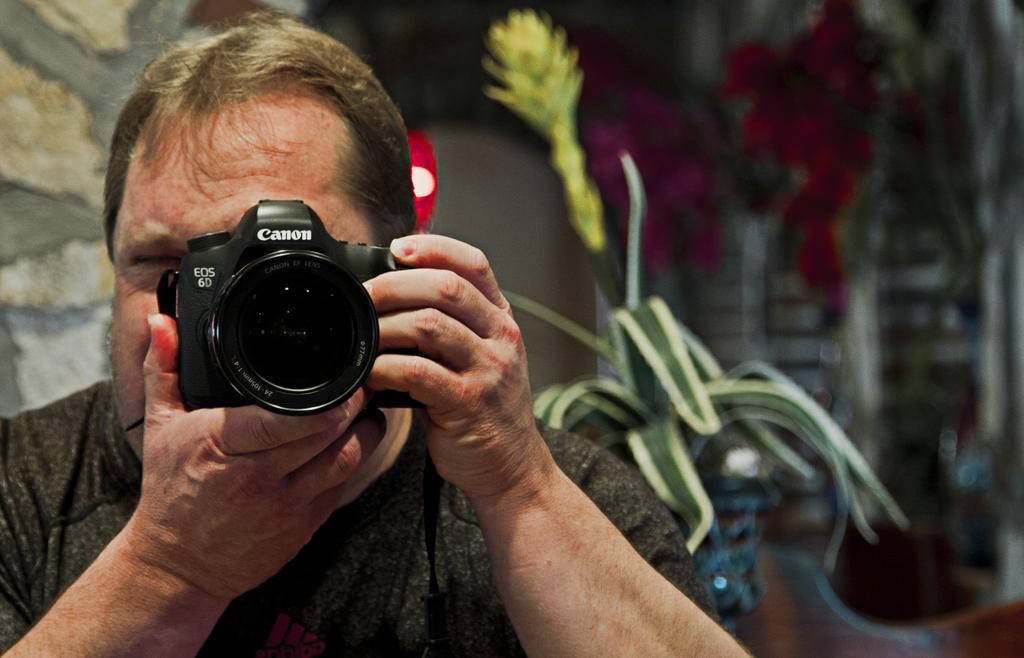Who is the main subject in the image? There is a person in the center of the image. What is the person holding in the image? The person is holding a camera. What can be seen in the background of the image? There is a wall and plants in the background of the image. What type of silk is draped over the wall in the image? There is no silk present in the image; it features a person holding a camera with a wall and plants in the background. 